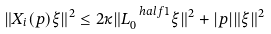<formula> <loc_0><loc_0><loc_500><loc_500>\| X _ { i } ( p ) \xi \| ^ { 2 } \leq 2 \kappa \| L _ { 0 } ^ { \ h a l f { 1 } } \xi \| ^ { 2 } + | p | \| \xi \| ^ { 2 }</formula> 